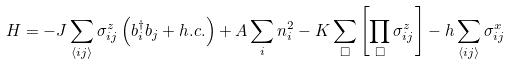Convert formula to latex. <formula><loc_0><loc_0><loc_500><loc_500>H = - J \sum _ { \langle i j \rangle } \sigma ^ { z } _ { i j } \left ( b ^ { \dagger } _ { i } b _ { j } + h . c . \right ) + A \sum _ { i } n ^ { 2 } _ { i } - K \sum _ { \Box } \left [ \prod _ { \Box } \sigma ^ { z } _ { i j } \right ] - h \sum _ { \langle i j \rangle } \sigma ^ { x } _ { i j }</formula> 